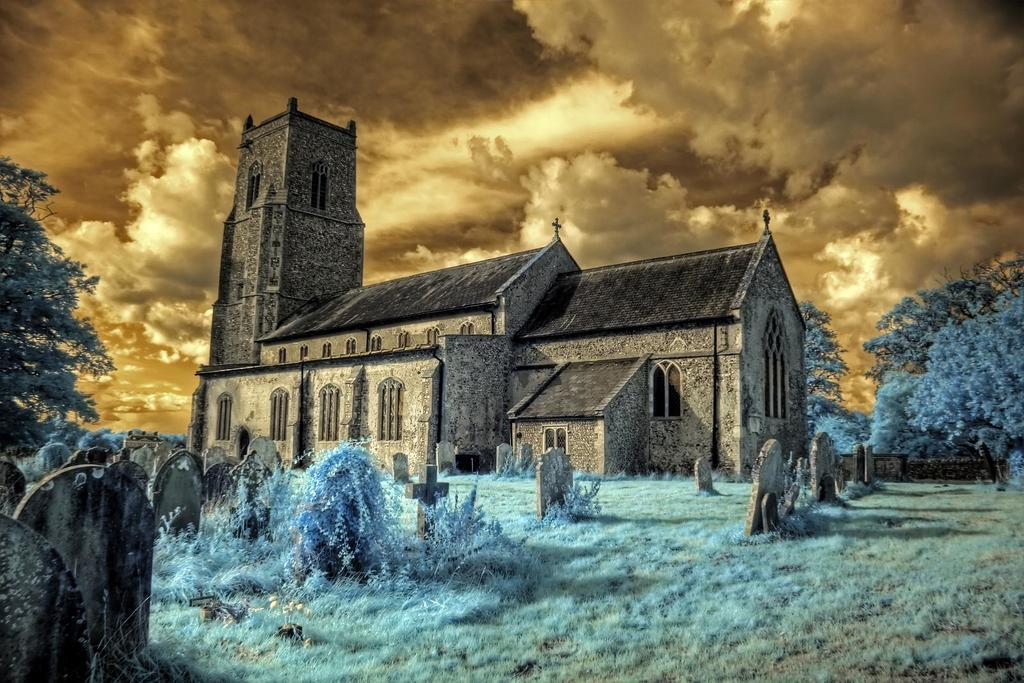How has the image been altered or modified? The image is edited. What type of structure can be seen in the image? There is a building with windows in the image. What type of memorial or burial site is present in the image? There is a group of grave stones in the image. What type of vegetation is present in the image? Grass, plants, and trees are visible in the image. What is visible in the sky in the image? The sky is visible in the image and appears cloudy. Can you see the partner of the person who is waving at the grave stones in the image? There is no person waving in the image, nor is there any indication of a partner. 